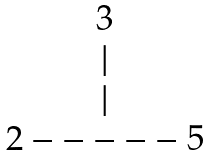<formula> <loc_0><loc_0><loc_500><loc_500>\begin{matrix} 3 \\ | \\ | \\ 2 - - - - - 5 \end{matrix}</formula> 